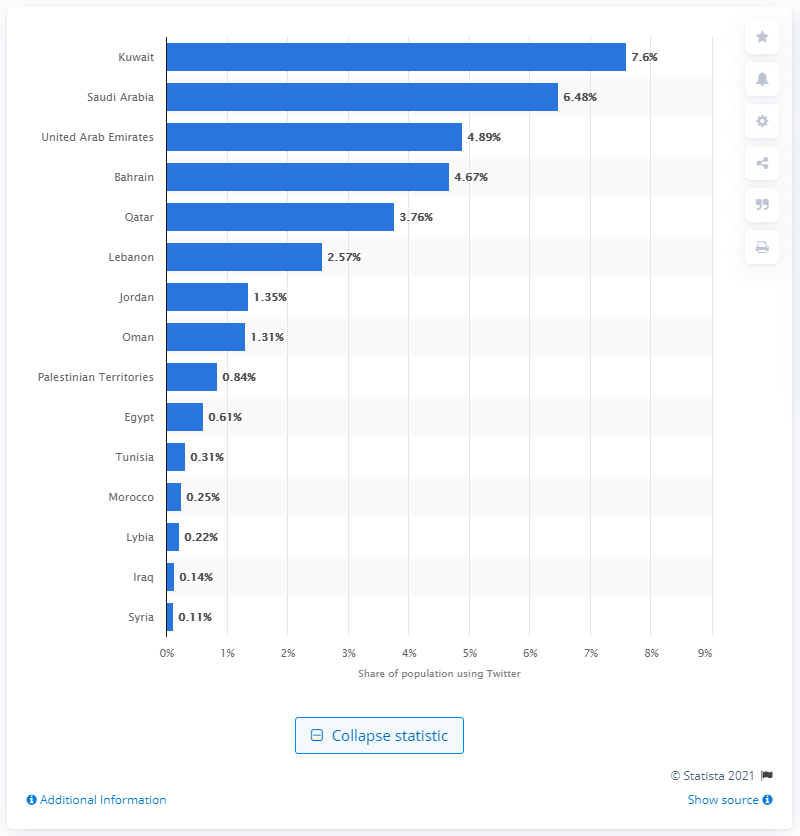Specify some key components in this picture. In March 2013, Kuwait had the highest Twitter usage rate among all countries. 